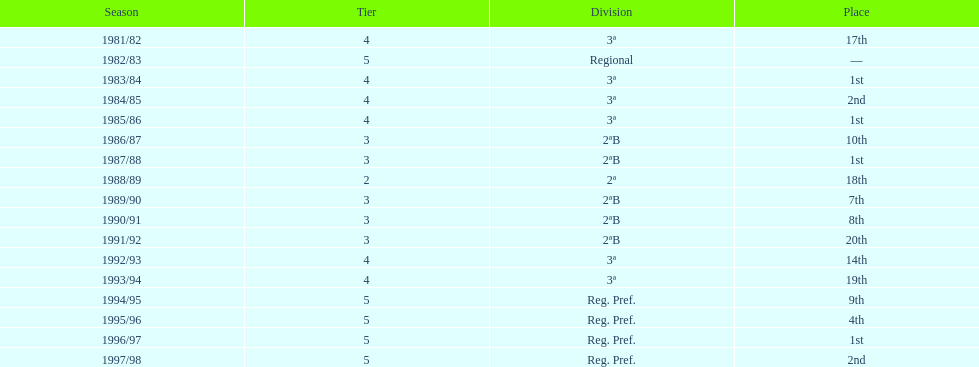When is the last year that the team has been division 2? 1991/92. Can you give me this table as a dict? {'header': ['Season', 'Tier', 'Division', 'Place'], 'rows': [['1981/82', '4', '3ª', '17th'], ['1982/83', '5', 'Regional', '—'], ['1983/84', '4', '3ª', '1st'], ['1984/85', '4', '3ª', '2nd'], ['1985/86', '4', '3ª', '1st'], ['1986/87', '3', '2ªB', '10th'], ['1987/88', '3', '2ªB', '1st'], ['1988/89', '2', '2ª', '18th'], ['1989/90', '3', '2ªB', '7th'], ['1990/91', '3', '2ªB', '8th'], ['1991/92', '3', '2ªB', '20th'], ['1992/93', '4', '3ª', '14th'], ['1993/94', '4', '3ª', '19th'], ['1994/95', '5', 'Reg. Pref.', '9th'], ['1995/96', '5', 'Reg. Pref.', '4th'], ['1996/97', '5', 'Reg. Pref.', '1st'], ['1997/98', '5', 'Reg. Pref.', '2nd']]} 